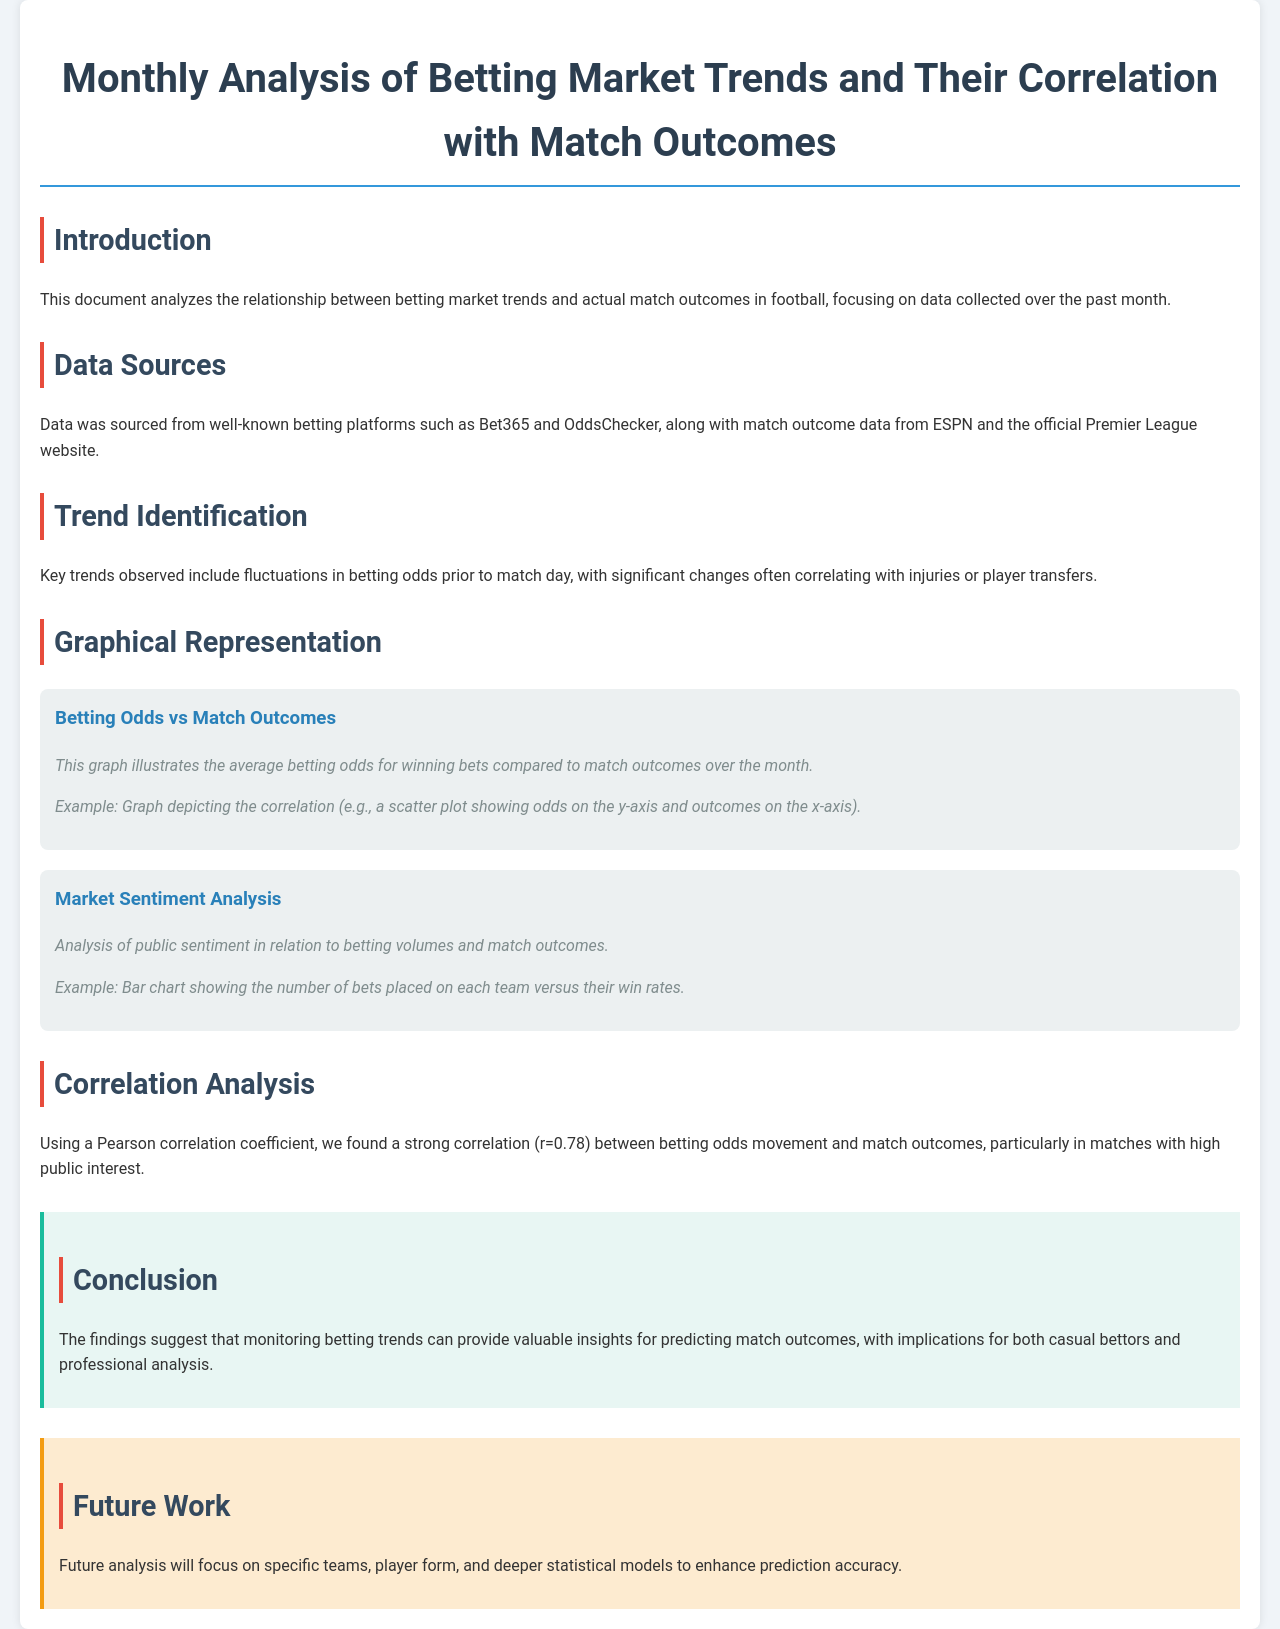What is the title of the document? The title of the document is stated at the top of the document.
Answer: Monthly Analysis of Betting Market Trends and Their Correlation with Match Outcomes What is the Pearson correlation coefficient found in the analysis? The correlation between betting odds movement and match outcomes is quantified in the correlation analysis section.
Answer: 0.78 Which platforms were used for data sourcing? The document lists specific platforms where data was sourced from.
Answer: Bet365 and OddsChecker What is the focus of the future work mentioned? The future work section highlights aspects that will be the subject of more detailed analysis.
Answer: Specific teams, player form, and deeper statistical models What is identified as a key trend in the analysis? The trends section discusses significant observations related to betting odds.
Answer: Fluctuations in betting odds prior to match day 